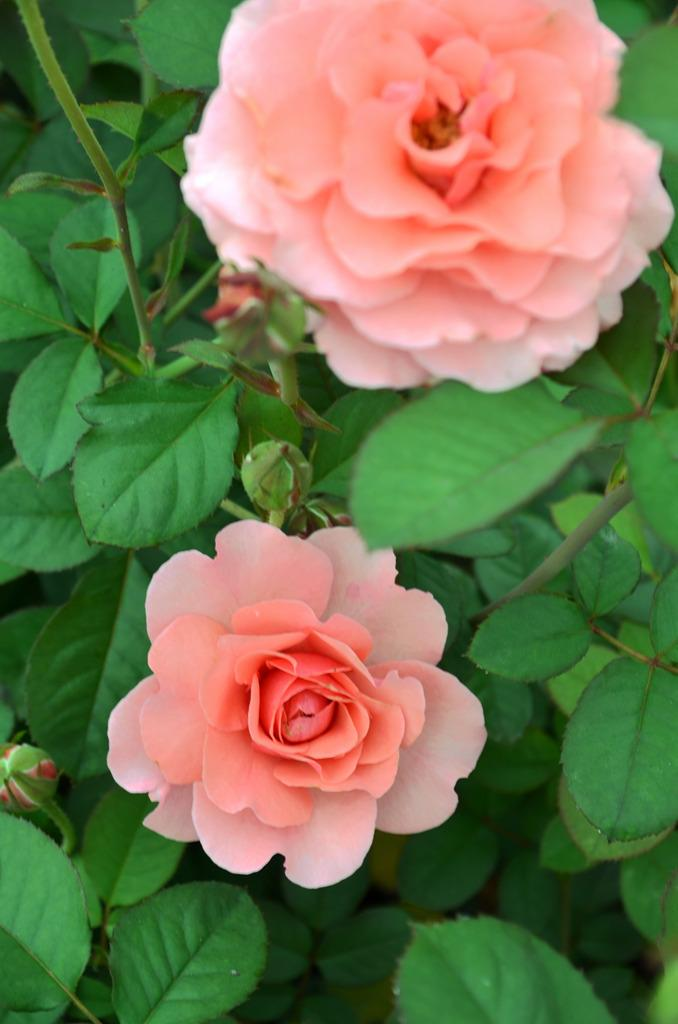What is the main subject of the image? There is a flower in the middle of the image. Are there any other flowers visible in the image? Yes, there is a flower at the top of the image. What type of sweater is the flower wearing in the image? There is no sweater present in the image, as flowers do not wear clothing. 